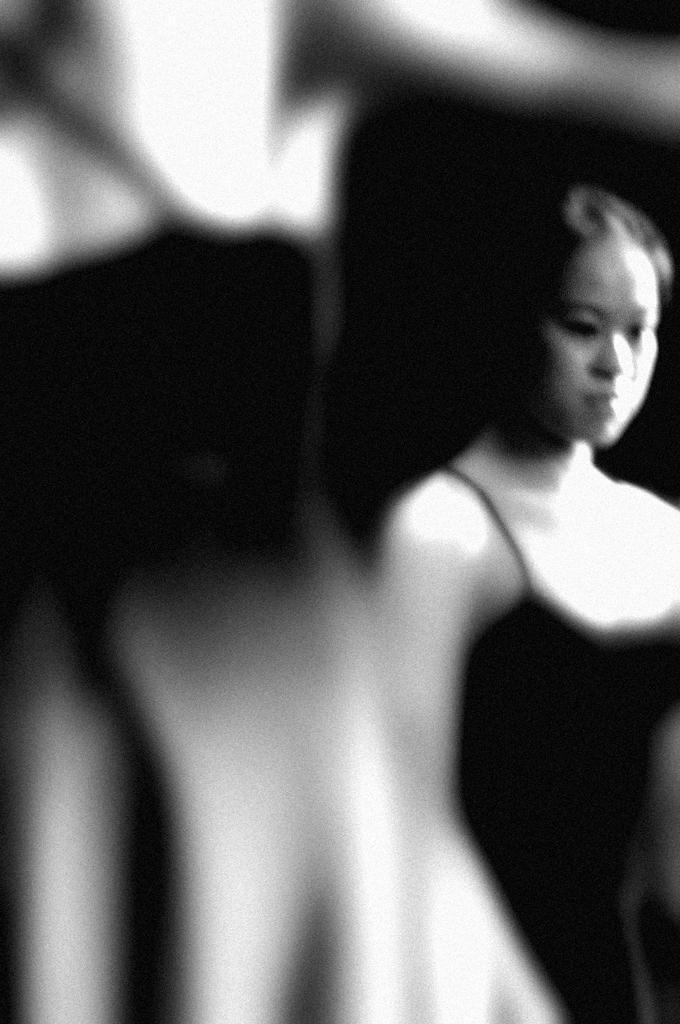What is the color scheme of the image? The image is black and white. Can you describe the person in the image? There is a lady in the image. What is the lady wearing? The lady is wearing a black dress. Is there any part of the image that is not clear? The left side of the image is blurry. What type of country is depicted in the background of the image? There is no country visible in the image, as it is a black and white photograph of a lady wearing a black dress. Can you see any patches on the lady's dress in the image? There are no patches visible on the lady's dress in the image; it is a solid black dress. 